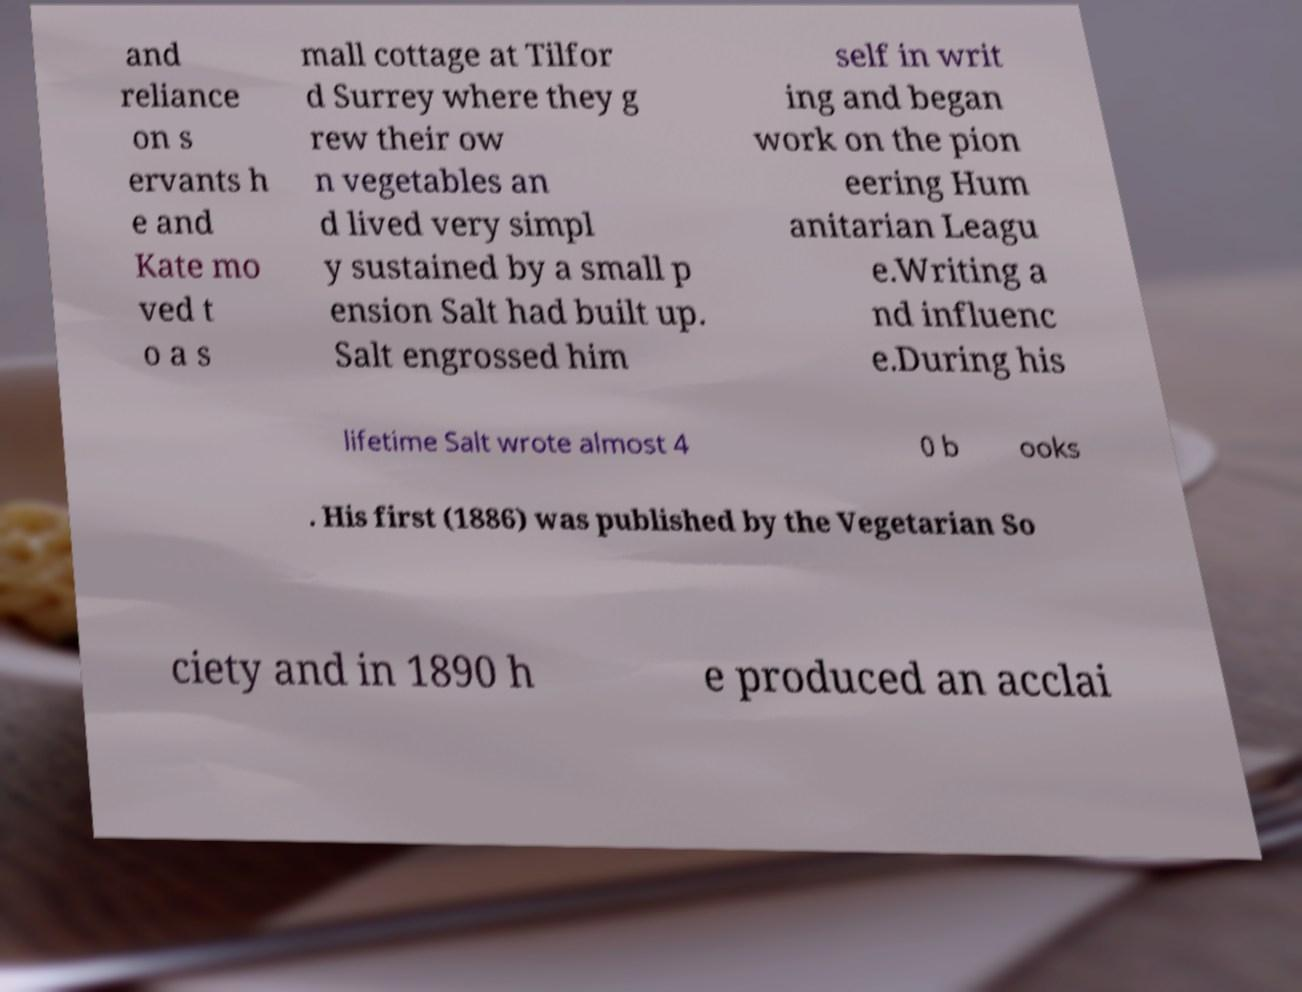Could you assist in decoding the text presented in this image and type it out clearly? and reliance on s ervants h e and Kate mo ved t o a s mall cottage at Tilfor d Surrey where they g rew their ow n vegetables an d lived very simpl y sustained by a small p ension Salt had built up. Salt engrossed him self in writ ing and began work on the pion eering Hum anitarian Leagu e.Writing a nd influenc e.During his lifetime Salt wrote almost 4 0 b ooks . His first (1886) was published by the Vegetarian So ciety and in 1890 h e produced an acclai 